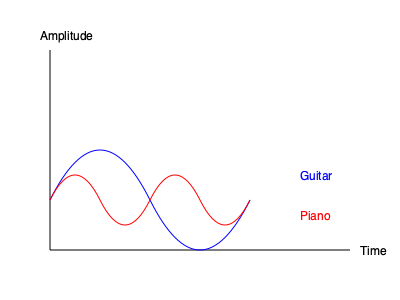In a live performance of Mary Chapin Carpenter, you notice distinct sound wave patterns for different instruments. Based on the graph showing wave patterns for a guitar and a piano, which instrument would likely have a richer overtone series and why? To answer this question, let's analyze the sound wave patterns step-by-step:

1. The blue line represents the guitar's sound wave, while the red line represents the piano's sound wave.

2. Observe that the guitar's wave pattern is smoother and has fewer peaks and troughs compared to the piano's wave pattern.

3. The piano's wave pattern shows more complex oscillations with multiple smaller peaks and troughs within each major cycle.

4. In music theory, overtones are additional frequencies above the fundamental frequency that give an instrument its unique timbre or tone color.

5. A richer overtone series means that an instrument produces more harmonics or partials above its fundamental frequency.

6. The complexity of the piano's wave pattern indicates the presence of more harmonics or overtones, as each additional peak or trough represents a different frequency component.

7. The guitar's smoother wave pattern suggests fewer overtones, resulting in a more "pure" tone.

8. Therefore, based on the graph, the piano would likely have a richer overtone series due to its more complex wave pattern.

This analysis aligns with the actual characteristics of these instruments. Pianos are known for their rich, complex tones due to the multiple strings per note and the resonance of the soundboard, which contribute to a wide range of overtones.
Answer: Piano, due to its more complex wave pattern indicating more harmonics. 